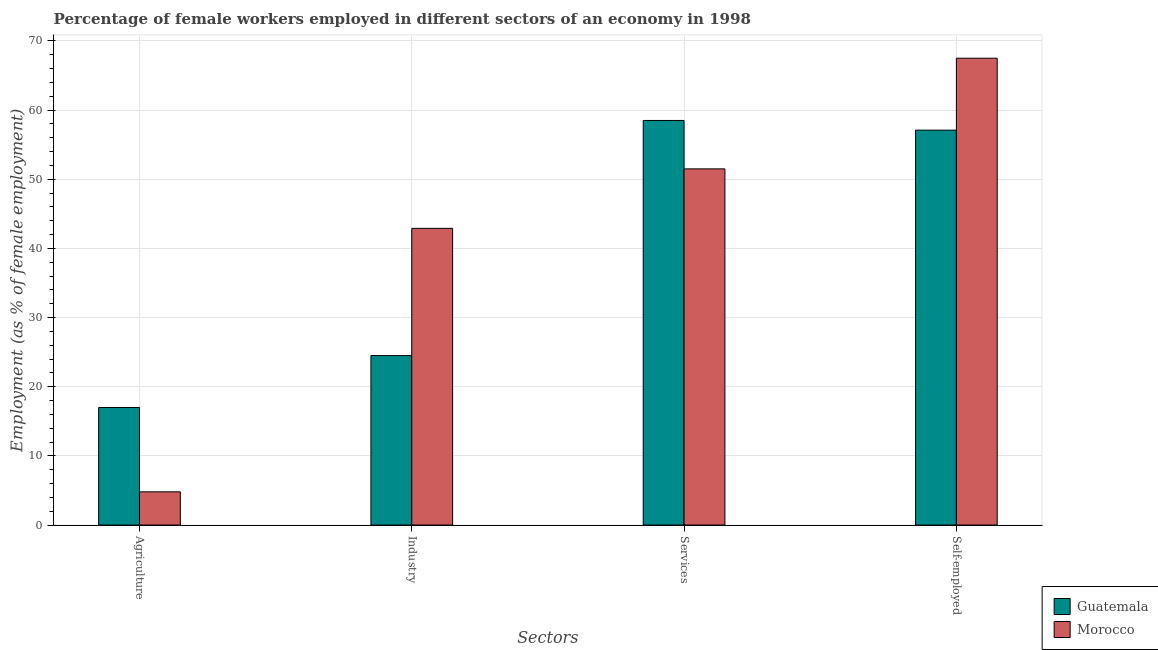How many different coloured bars are there?
Keep it short and to the point. 2. Are the number of bars per tick equal to the number of legend labels?
Your answer should be compact. Yes. Are the number of bars on each tick of the X-axis equal?
Your response must be concise. Yes. How many bars are there on the 2nd tick from the right?
Give a very brief answer. 2. What is the label of the 2nd group of bars from the left?
Ensure brevity in your answer.  Industry. Across all countries, what is the minimum percentage of female workers in agriculture?
Your answer should be compact. 4.8. In which country was the percentage of female workers in agriculture maximum?
Your answer should be very brief. Guatemala. In which country was the percentage of female workers in industry minimum?
Keep it short and to the point. Guatemala. What is the total percentage of self employed female workers in the graph?
Ensure brevity in your answer.  124.6. What is the difference between the percentage of female workers in agriculture in Morocco and that in Guatemala?
Provide a short and direct response. -12.2. What is the average percentage of female workers in agriculture per country?
Your answer should be compact. 10.9. In how many countries, is the percentage of female workers in services greater than 34 %?
Give a very brief answer. 2. What is the ratio of the percentage of female workers in industry in Morocco to that in Guatemala?
Offer a terse response. 1.75. Is the difference between the percentage of female workers in industry in Guatemala and Morocco greater than the difference between the percentage of self employed female workers in Guatemala and Morocco?
Offer a very short reply. No. What is the difference between the highest and the second highest percentage of female workers in agriculture?
Give a very brief answer. 12.2. What is the difference between the highest and the lowest percentage of female workers in services?
Offer a very short reply. 7. In how many countries, is the percentage of female workers in industry greater than the average percentage of female workers in industry taken over all countries?
Give a very brief answer. 1. Is the sum of the percentage of self employed female workers in Guatemala and Morocco greater than the maximum percentage of female workers in industry across all countries?
Ensure brevity in your answer.  Yes. What does the 1st bar from the left in Industry represents?
Offer a terse response. Guatemala. What does the 1st bar from the right in Agriculture represents?
Your response must be concise. Morocco. Are all the bars in the graph horizontal?
Ensure brevity in your answer.  No. Are the values on the major ticks of Y-axis written in scientific E-notation?
Your answer should be very brief. No. Where does the legend appear in the graph?
Ensure brevity in your answer.  Bottom right. How are the legend labels stacked?
Offer a terse response. Vertical. What is the title of the graph?
Provide a short and direct response. Percentage of female workers employed in different sectors of an economy in 1998. What is the label or title of the X-axis?
Your answer should be compact. Sectors. What is the label or title of the Y-axis?
Provide a succinct answer. Employment (as % of female employment). What is the Employment (as % of female employment) of Morocco in Agriculture?
Your answer should be very brief. 4.8. What is the Employment (as % of female employment) in Guatemala in Industry?
Provide a succinct answer. 24.5. What is the Employment (as % of female employment) of Morocco in Industry?
Your answer should be compact. 42.9. What is the Employment (as % of female employment) of Guatemala in Services?
Provide a short and direct response. 58.5. What is the Employment (as % of female employment) in Morocco in Services?
Ensure brevity in your answer.  51.5. What is the Employment (as % of female employment) of Guatemala in Self-employed?
Offer a very short reply. 57.1. What is the Employment (as % of female employment) of Morocco in Self-employed?
Your response must be concise. 67.5. Across all Sectors, what is the maximum Employment (as % of female employment) of Guatemala?
Provide a succinct answer. 58.5. Across all Sectors, what is the maximum Employment (as % of female employment) in Morocco?
Keep it short and to the point. 67.5. Across all Sectors, what is the minimum Employment (as % of female employment) of Guatemala?
Ensure brevity in your answer.  17. Across all Sectors, what is the minimum Employment (as % of female employment) in Morocco?
Make the answer very short. 4.8. What is the total Employment (as % of female employment) in Guatemala in the graph?
Keep it short and to the point. 157.1. What is the total Employment (as % of female employment) of Morocco in the graph?
Provide a succinct answer. 166.7. What is the difference between the Employment (as % of female employment) in Morocco in Agriculture and that in Industry?
Offer a terse response. -38.1. What is the difference between the Employment (as % of female employment) in Guatemala in Agriculture and that in Services?
Offer a very short reply. -41.5. What is the difference between the Employment (as % of female employment) of Morocco in Agriculture and that in Services?
Offer a terse response. -46.7. What is the difference between the Employment (as % of female employment) in Guatemala in Agriculture and that in Self-employed?
Your answer should be compact. -40.1. What is the difference between the Employment (as % of female employment) of Morocco in Agriculture and that in Self-employed?
Make the answer very short. -62.7. What is the difference between the Employment (as % of female employment) of Guatemala in Industry and that in Services?
Offer a terse response. -34. What is the difference between the Employment (as % of female employment) of Morocco in Industry and that in Services?
Provide a short and direct response. -8.6. What is the difference between the Employment (as % of female employment) of Guatemala in Industry and that in Self-employed?
Your answer should be compact. -32.6. What is the difference between the Employment (as % of female employment) of Morocco in Industry and that in Self-employed?
Provide a short and direct response. -24.6. What is the difference between the Employment (as % of female employment) of Morocco in Services and that in Self-employed?
Ensure brevity in your answer.  -16. What is the difference between the Employment (as % of female employment) of Guatemala in Agriculture and the Employment (as % of female employment) of Morocco in Industry?
Ensure brevity in your answer.  -25.9. What is the difference between the Employment (as % of female employment) in Guatemala in Agriculture and the Employment (as % of female employment) in Morocco in Services?
Your answer should be very brief. -34.5. What is the difference between the Employment (as % of female employment) in Guatemala in Agriculture and the Employment (as % of female employment) in Morocco in Self-employed?
Your answer should be compact. -50.5. What is the difference between the Employment (as % of female employment) of Guatemala in Industry and the Employment (as % of female employment) of Morocco in Self-employed?
Ensure brevity in your answer.  -43. What is the average Employment (as % of female employment) in Guatemala per Sectors?
Provide a succinct answer. 39.27. What is the average Employment (as % of female employment) in Morocco per Sectors?
Make the answer very short. 41.67. What is the difference between the Employment (as % of female employment) of Guatemala and Employment (as % of female employment) of Morocco in Industry?
Offer a terse response. -18.4. What is the ratio of the Employment (as % of female employment) of Guatemala in Agriculture to that in Industry?
Provide a succinct answer. 0.69. What is the ratio of the Employment (as % of female employment) of Morocco in Agriculture to that in Industry?
Make the answer very short. 0.11. What is the ratio of the Employment (as % of female employment) of Guatemala in Agriculture to that in Services?
Your response must be concise. 0.29. What is the ratio of the Employment (as % of female employment) of Morocco in Agriculture to that in Services?
Offer a very short reply. 0.09. What is the ratio of the Employment (as % of female employment) in Guatemala in Agriculture to that in Self-employed?
Provide a succinct answer. 0.3. What is the ratio of the Employment (as % of female employment) in Morocco in Agriculture to that in Self-employed?
Provide a short and direct response. 0.07. What is the ratio of the Employment (as % of female employment) in Guatemala in Industry to that in Services?
Offer a very short reply. 0.42. What is the ratio of the Employment (as % of female employment) of Morocco in Industry to that in Services?
Keep it short and to the point. 0.83. What is the ratio of the Employment (as % of female employment) of Guatemala in Industry to that in Self-employed?
Keep it short and to the point. 0.43. What is the ratio of the Employment (as % of female employment) of Morocco in Industry to that in Self-employed?
Give a very brief answer. 0.64. What is the ratio of the Employment (as % of female employment) in Guatemala in Services to that in Self-employed?
Provide a short and direct response. 1.02. What is the ratio of the Employment (as % of female employment) of Morocco in Services to that in Self-employed?
Provide a succinct answer. 0.76. What is the difference between the highest and the second highest Employment (as % of female employment) in Morocco?
Your answer should be compact. 16. What is the difference between the highest and the lowest Employment (as % of female employment) of Guatemala?
Your answer should be compact. 41.5. What is the difference between the highest and the lowest Employment (as % of female employment) of Morocco?
Your response must be concise. 62.7. 